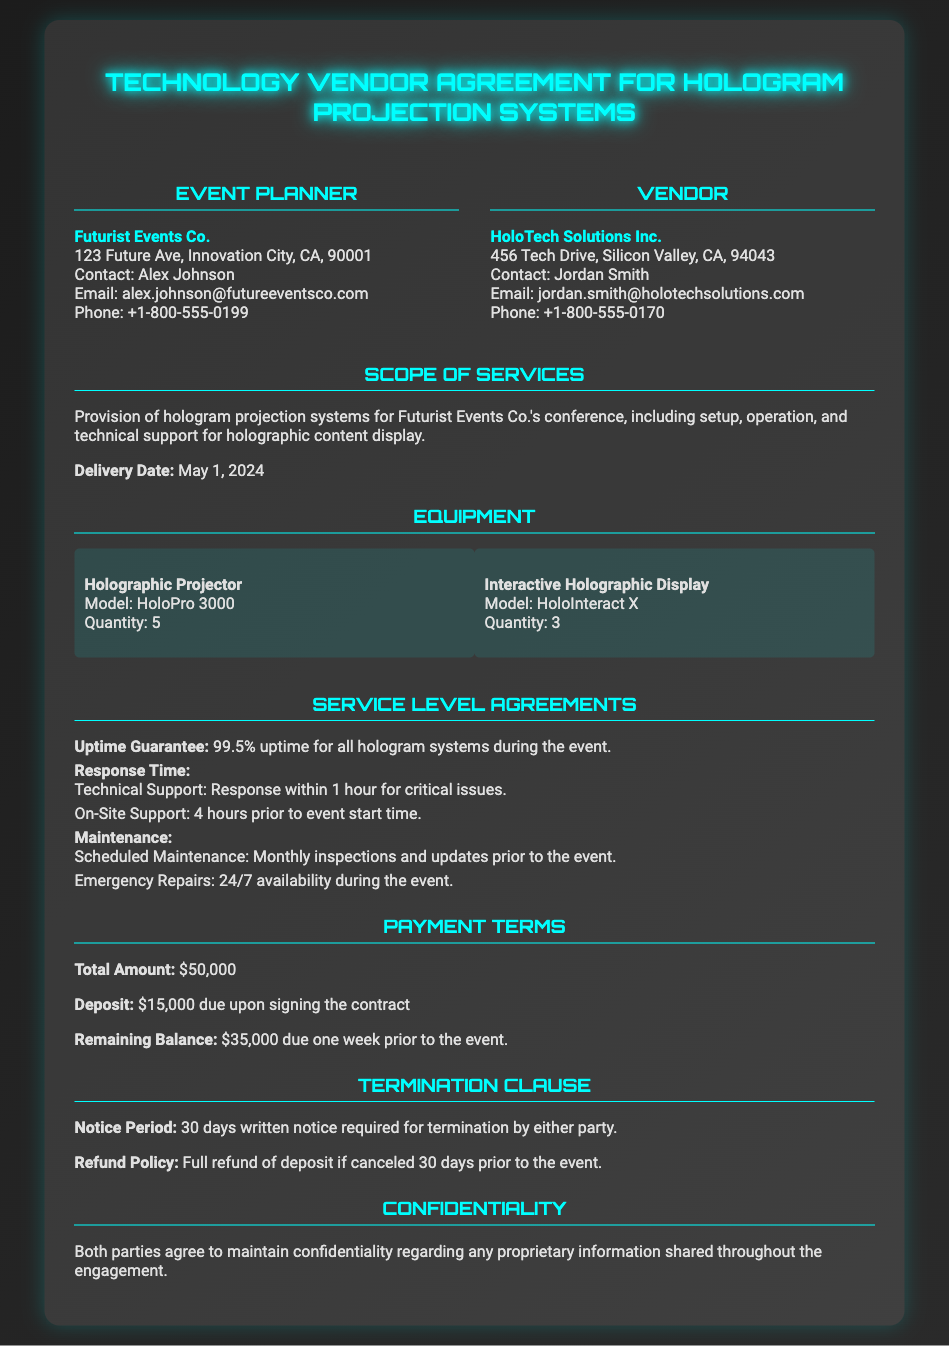What is the name of the event planning company? The event planning company is mentioned as Futurist Events Co. in the document.
Answer: Futurist Events Co What is the total amount for the services? The document specifies the total amount for the services as $50,000.
Answer: $50,000 What is the uptime guarantee provided in the agreement? The agreement states the uptime guarantee is 99.5% for all hologram systems.
Answer: 99.5% When is the delivery date for the hologram projection systems? The document mentions the delivery date as May 1, 2024.
Answer: May 1, 2024 What are the models of the holographic projector and display? The models listed are HoloPro 3000 for the projector and HoloInteract X for the display.
Answer: HoloPro 3000, HoloInteract X What is the notice period required for termination by either party? The document states that a 30 days written notice is required for termination.
Answer: 30 days How much is the deposit due upon signing the contract? The deposit required upon signing the contract is specified as $15,000.
Answer: $15,000 What kind of maintenance is included in the service level agreement? The maintenance includes scheduled monthly inspections and updates, as well as 24/7 emergency repairs during the event.
Answer: Scheduled monthly inspections and updates; 24/7 emergency repairs What is the refund policy if the agreement is canceled 30 days prior to the event? The document outlines a full refund of the deposit if canceled 30 days prior to the event.
Answer: Full refund of deposit 